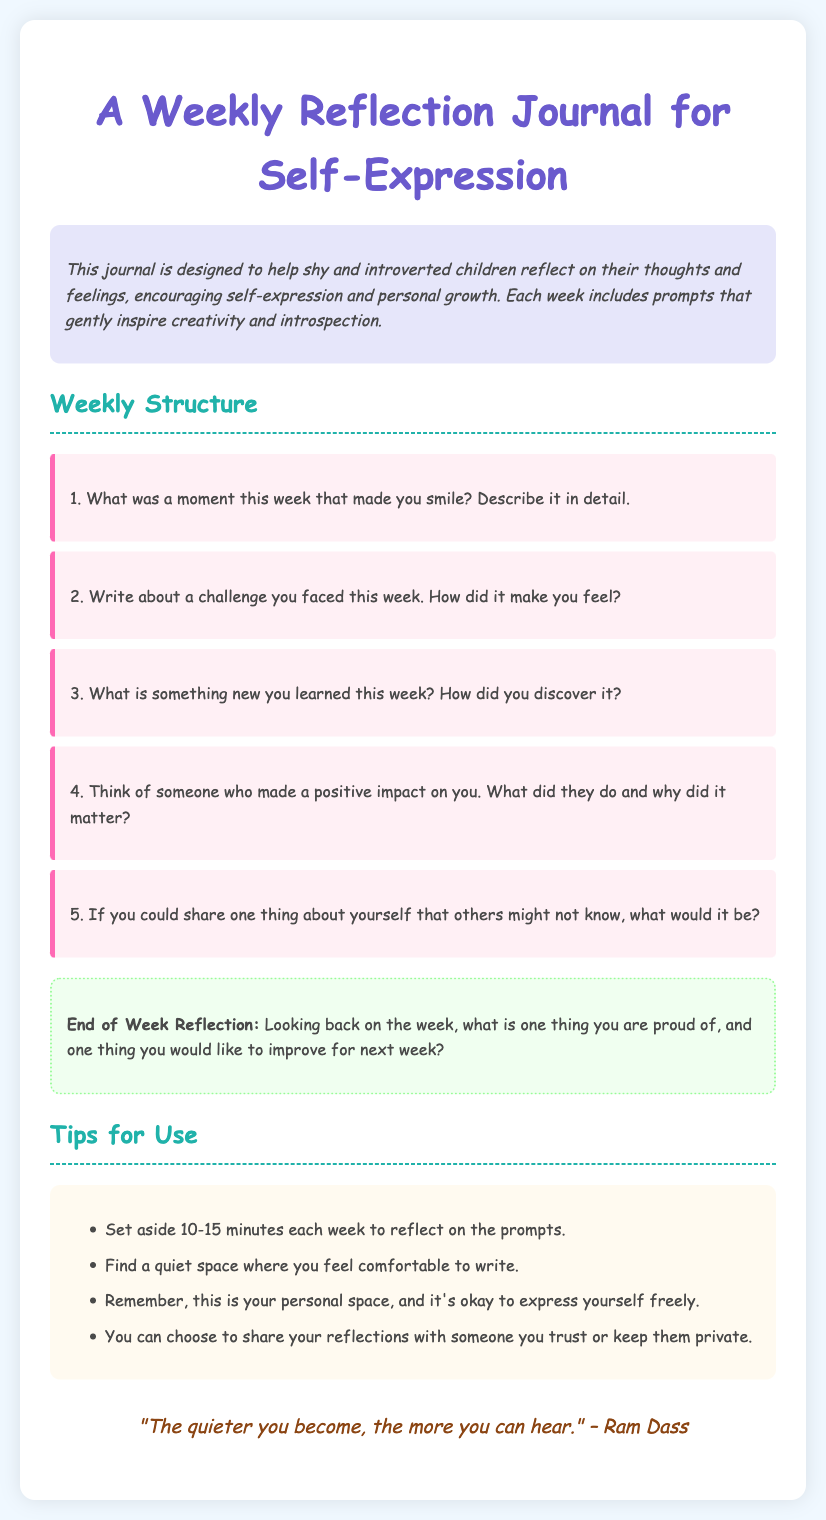What is the title of the journal? The title of the journal is mentioned at the very top of the document.
Answer: A Weekly Reflection Journal for Self-Expression How many weekly prompts are there? The number of prompts can be tallied from the list provided under the "Weekly Structure" section.
Answer: 5 What is the color of the background in the document? The document specifies the background color used in its styling.
Answer: #f0f8ff What quote is included in the document? The quote presented is found at the end of the journal and is relevant to self-reflection.
Answer: "The quieter you become, the more you can hear." – Ram Dass What should you set aside for reflection each week? The document advises a specific amount of time noted in the "Tips for Use" section.
Answer: 10-15 minutes What is the purpose of this journal? The purpose is summarized in the introductory paragraph.
Answer: Encourage self-expression and personal growth 